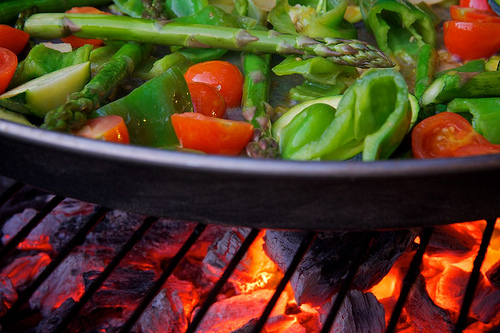<image>
Is the cherry tomatoes to the left of the asparagus? No. The cherry tomatoes is not to the left of the asparagus. From this viewpoint, they have a different horizontal relationship. 